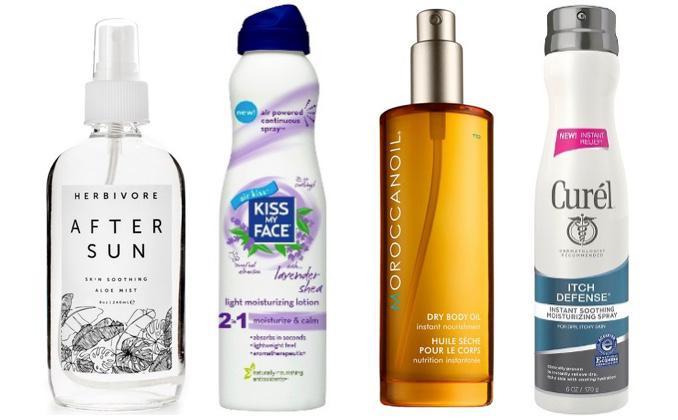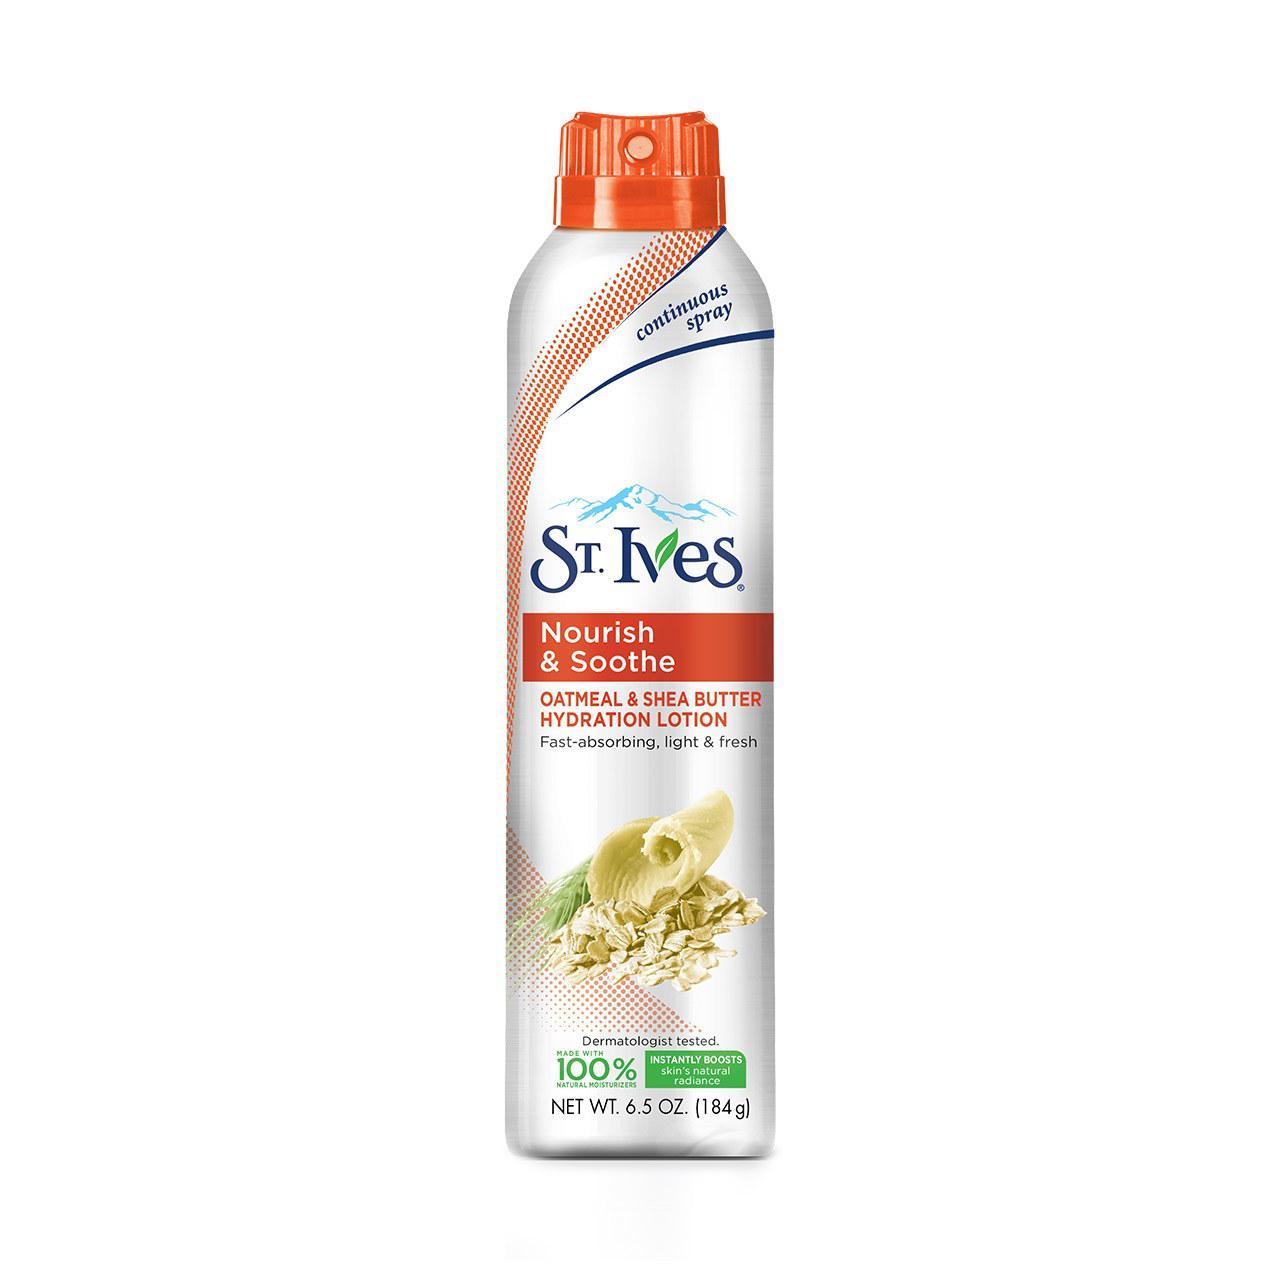The first image is the image on the left, the second image is the image on the right. Given the left and right images, does the statement "there are 7 beauty products in the image pair" hold true? Answer yes or no. No. The first image is the image on the left, the second image is the image on the right. Considering the images on both sides, is "The image on the left has one bottle of St. Ives Fresh Hydration Lotion in front of objects that match the objects on the bottle." valid? Answer yes or no. No. 